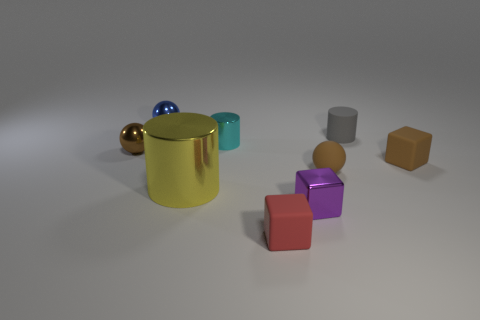Add 1 large purple metallic cubes. How many objects exist? 10 Subtract all blocks. How many objects are left? 6 Add 2 small cyan cylinders. How many small cyan cylinders exist? 3 Subtract 1 cyan cylinders. How many objects are left? 8 Subtract all small blue shiny things. Subtract all small metallic cylinders. How many objects are left? 7 Add 9 metallic blocks. How many metallic blocks are left? 10 